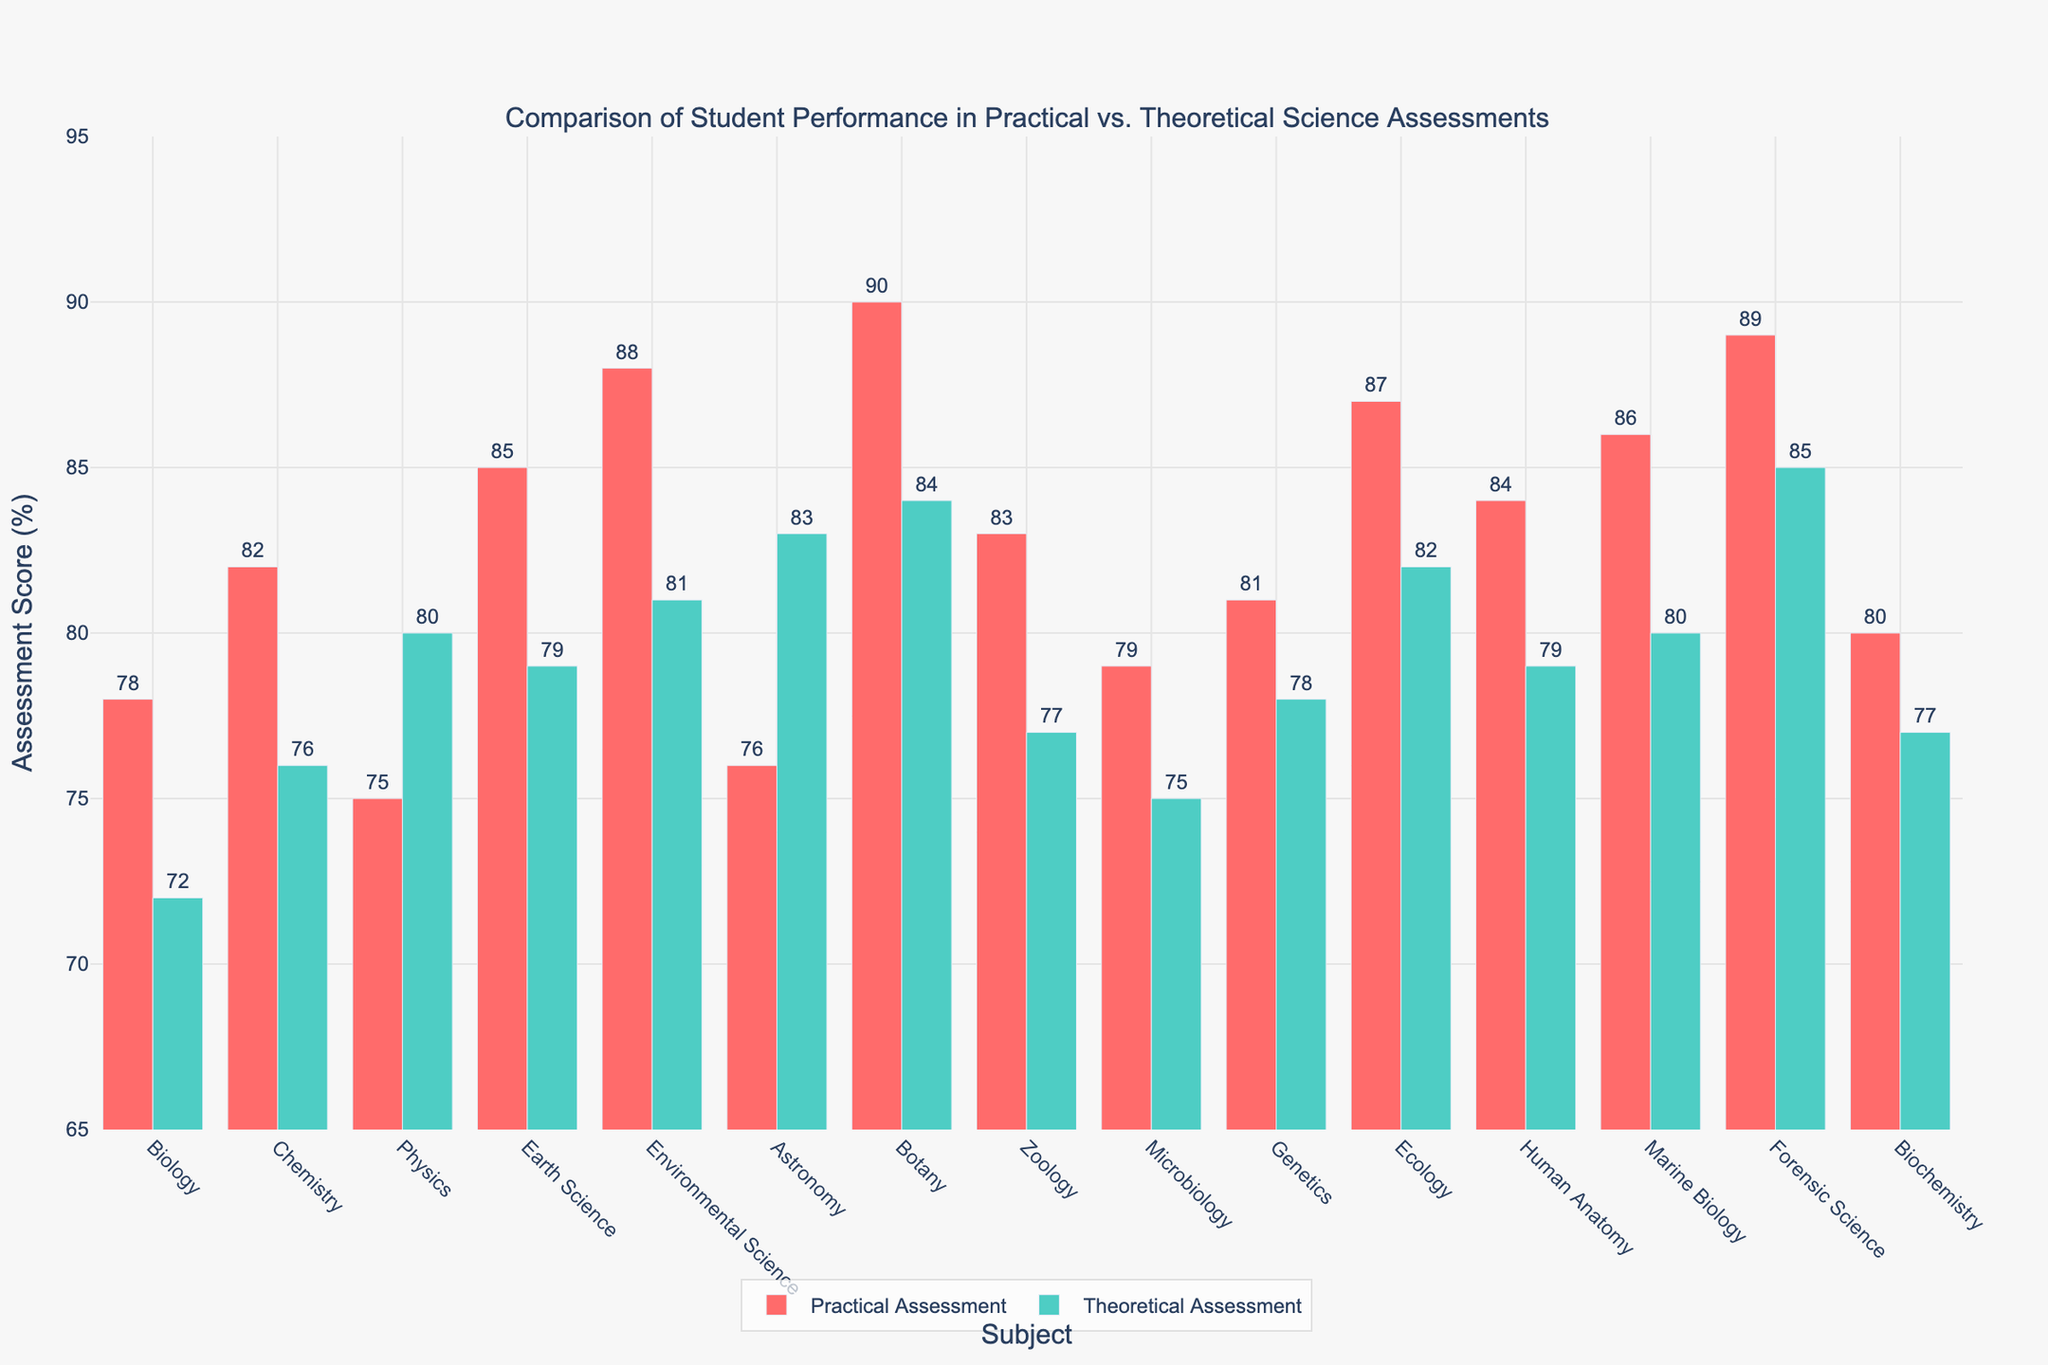What's the difference between the Practical and Theoretical scores for Biology? To get the difference, subtract the Theoretical score from the Practical score for Biology. That is 78 - 72 = 6.
Answer: 6 Which subject shows the highest Practical Assessment Score? By examining the height of the red bars, Botany has the highest Practical Assessment Score of 90.
Answer: Botany Which subject shows the highest Theoretical Assessment Score? By examining the height of the green bars, Forensic Science has the highest Theoretical Assessment Score of 85.
Answer: Forensic Science On average, which is higher, Practical or Theoretical scores? Calculate the average for both Practical and Theoretical scores. Practical: (78+82+75+85+88+76+90+83+79+81+87+84+86+89+80) / 15 = 83 Theoretical: (72+76+80+79+81+83+84+77+75+78+82+79+80+85+77) / 15 = 79.6 Thus, the average Practical score is higher than the average Theoretical score.
Answer: Practical scores For Ecology, is the Practical or Theoretical score higher? Compare the Practical score (87%) with the Theoretical score (82%) for Ecology. The Practical score is higher.
Answer: Practical score How many subjects have a higher Practical score compared to their Theoretical score? By visually comparing the heights of the red and green bars: Biology, Chemistry, Earth Science, Environmental Science, Microbiology, Genetics, Ecology, Human Anatomy, Marine Biology, Forensic Science, Biochemistry (11 subjects) have higher Practical scores.
Answer: 11 What's the total Practical score across all subjects? Sum all Practical scores: 78+82+75+85+88+76+90+83+79+81+87+84+86+89+80 = 1263.
Answer: 1263 What is the range of Theoretical scores across all subjects? Find the minimum and maximum Theoretical scores: 72 (Biology) and 85 (Forensic Science). Then, 85 - 72 = 13.
Answer: 13 Which subjects have equal Practical and Theoretical scores? Checking each subject's Practical and Theoretical scores, no subjects have equal scores.
Answer: None 